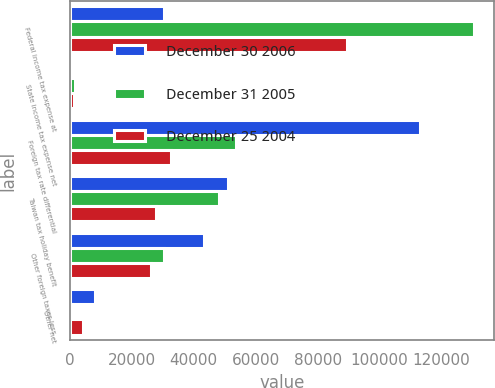Convert chart to OTSL. <chart><loc_0><loc_0><loc_500><loc_500><stacked_bar_chart><ecel><fcel>Federal income tax expense at<fcel>State income tax expense net<fcel>Foreign tax rate differential<fcel>Taiwan tax holiday benefit<fcel>Other foreign taxes less<fcel>Other net<nl><fcel>December 30 2006<fcel>30427<fcel>658<fcel>112903<fcel>50905<fcel>43445<fcel>7958<nl><fcel>December 31 2005<fcel>130410<fcel>1666<fcel>53712<fcel>48175<fcel>30427<fcel>765<nl><fcel>December 25 2004<fcel>89324<fcel>1303<fcel>32516<fcel>27753<fcel>26080<fcel>4321<nl></chart> 